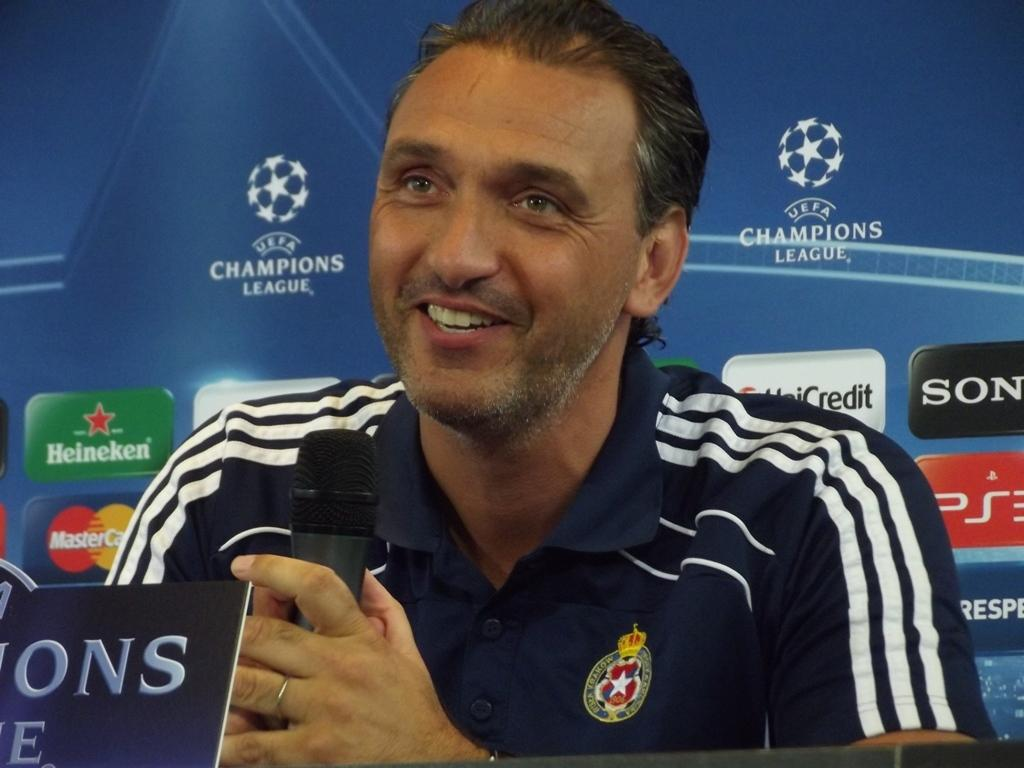What is the main subject of the image? There is a person in the image. What is the person holding in the image? The person is holding a microphone. What color is the shirt the person is wearing? The person is wearing a blue color shirt. Can you describe the background of the image? There is a blue color board in the background of the image. What type of insurance policy is being discussed in the image? There is no mention of insurance in the image; it features a person holding a microphone and wearing a blue color shirt with a blue color board in the background. 